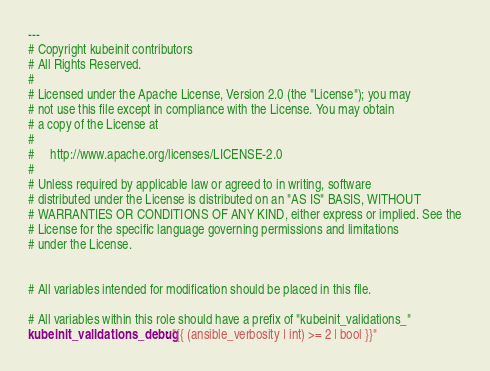<code> <loc_0><loc_0><loc_500><loc_500><_YAML_>---
# Copyright kubeinit contributors
# All Rights Reserved.
#
# Licensed under the Apache License, Version 2.0 (the "License"); you may
# not use this file except in compliance with the License. You may obtain
# a copy of the License at
#
#     http://www.apache.org/licenses/LICENSE-2.0
#
# Unless required by applicable law or agreed to in writing, software
# distributed under the License is distributed on an "AS IS" BASIS, WITHOUT
# WARRANTIES OR CONDITIONS OF ANY KIND, either express or implied. See the
# License for the specific language governing permissions and limitations
# under the License.


# All variables intended for modification should be placed in this file.

# All variables within this role should have a prefix of "kubeinit_validations_"
kubeinit_validations_debug: "{{ (ansible_verbosity | int) >= 2 | bool }}"</code> 